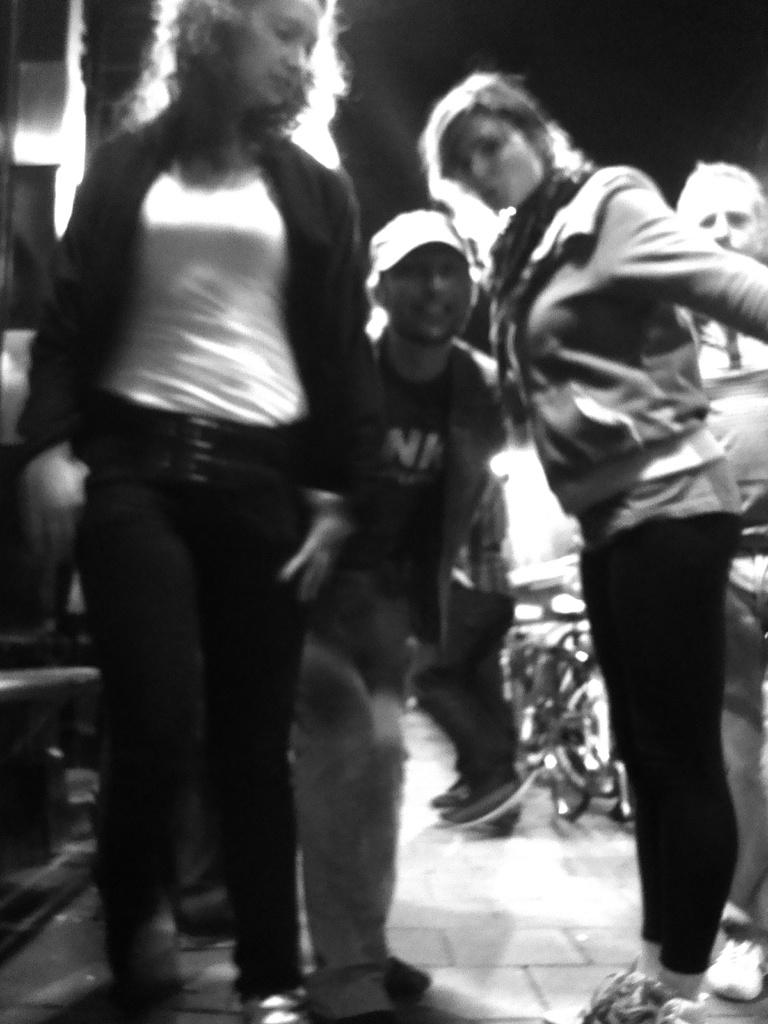What is happening in the image? There are people in motion in the image. What can be observed about the lighting in the image? The background of the image is dark. Can you see a potato being touched by someone in the image? There is no potato present in the image, and therefore no such interaction can be observed. What type of street is visible in the image? There is no street visible in the image; it features people in motion against a dark background. 